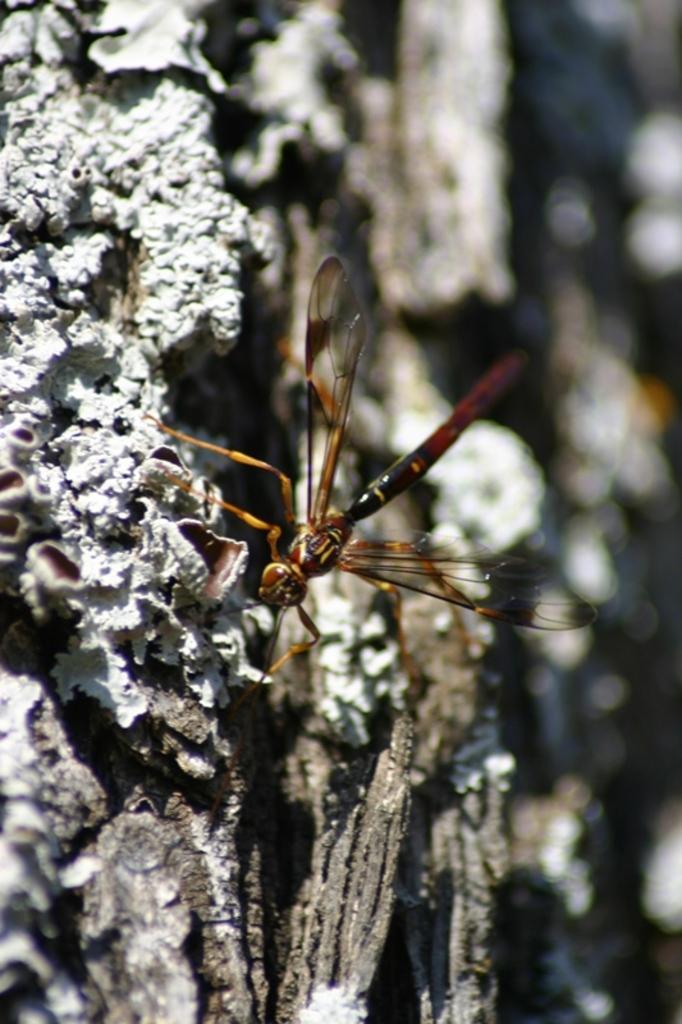Could you give a brief overview of what you see in this image? It looks like a rock and on the rock there is a dragonfly. Behind the dragonfly there is the blurred background. 